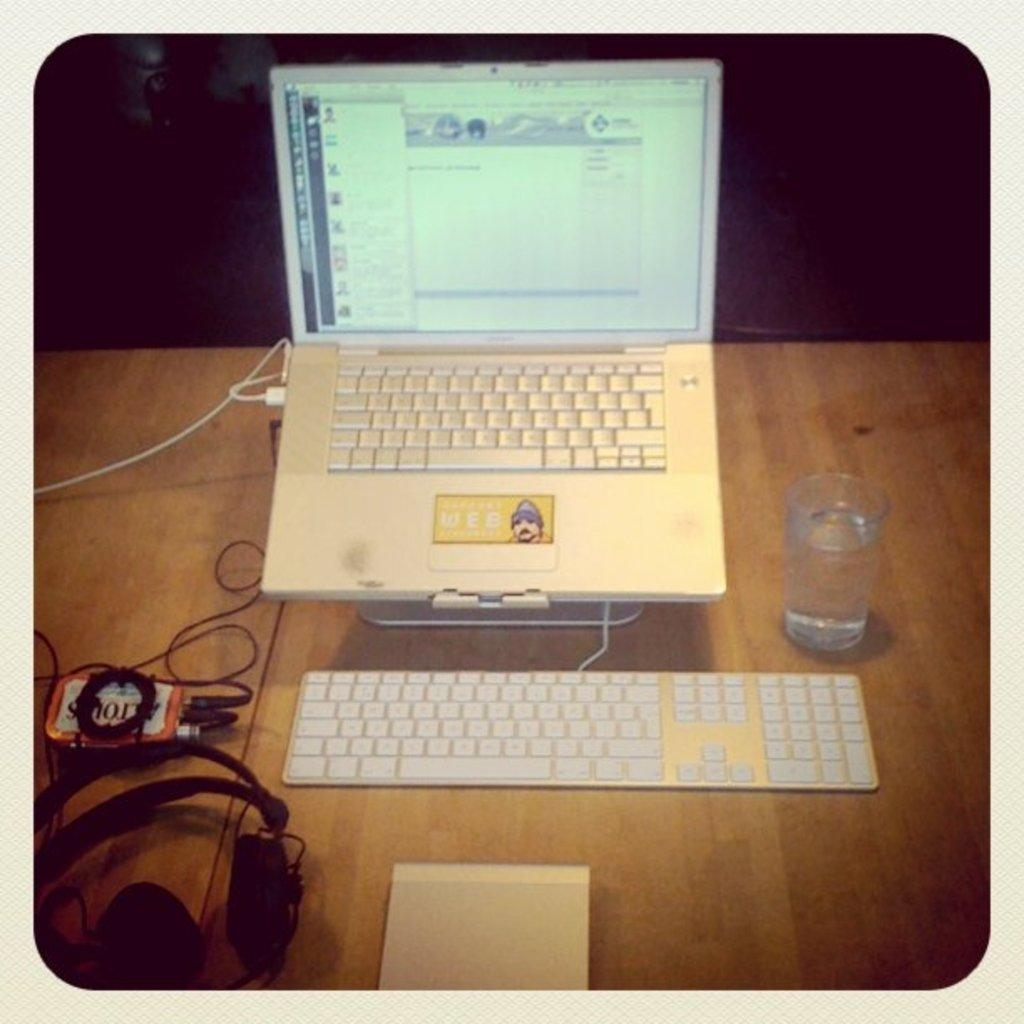What electronic device is visible in the image? There is a laptop in the image. What other input device can be seen in the image? There is another keyboard in the image. What can be seen on the left side of the image? There are wires on the left side of the image. What is on the right side of the image? There is a glass of water on the right side of the image. What type of battle is taking place in the image? There is no battle present in the image; it features a laptop, another keyboard, wires, and a glass of water. Whose birthday is being celebrated in the image? There is no indication of a birthday celebration in the image. 